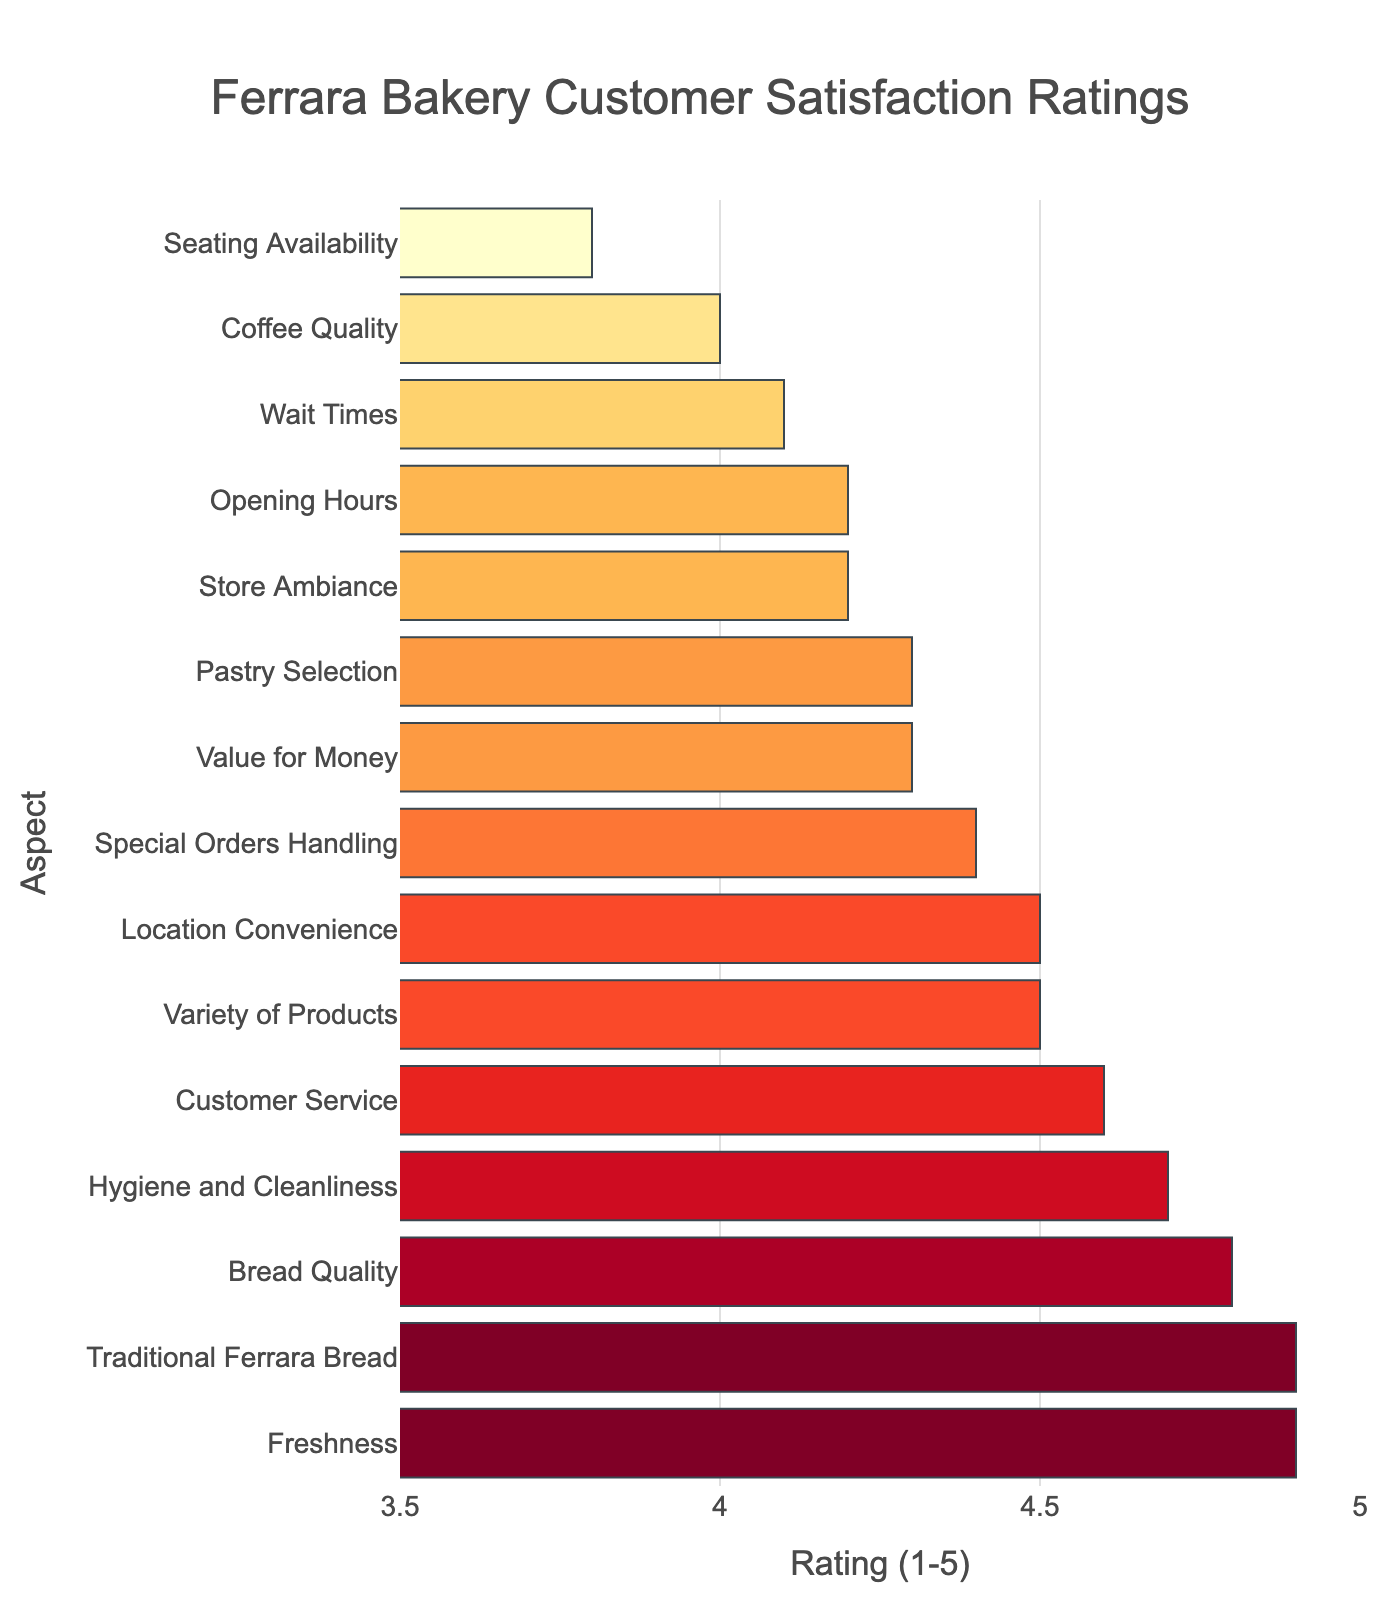How many aspects have a rating of 4.0 or below? Check each rating and count how many are 4.0 or below. In the provided data, ‘Coffee Quality’ has a rating of 4.0, and ‘Seating Availability’ has a rating of 3.8.
Answer: 2 Which aspect has the maximum customer satisfaction rating? Identify the highest rating in the data. Both ‘Freshness’ and 'Traditional Ferrara Bread' have the highest rating of 4.9.
Answer: Freshness/Traditional Ferrara Bread (Tie) What is the average rating for all aspects? Sum all ratings and divide by the number of aspects. The sum is 65.8, and there are 15 aspects: 65.8/15 = 4.39.
Answer: 4.39 Which aspects have a higher rating than the 'Store Ambiance'? 'Store Ambiance' has a rating of 4.2. Compare other ratings to find higher values: Bread Quality (4.8), Customer Service (4.6), Variety of Products (4.5), Freshness (4.9), Value for Money (4.3), Hygiene and Cleanliness (4.7), Special Orders Handling (4.4), Traditional Ferrara Bread (4.9), Location Convenience (4.5).
Answer: Bread Quality, Customer Service, Variety of Products, Freshness, Value for Money, Hygiene and Cleanliness, Special Orders Handling, Traditional Ferrara Bread, Location Convenience What is the median rating across all aspects? Arrange ratings in ascending order:  (3.8, 4.0, 4.1, 4.2, 4.2, 4.3, 4.3, 4.4, 4.5, 4.5, 4.6, 4.7, 4.8, 4.9, 4.9). The median is the middle value: (4.4 + 4.5)/2 = 4.45.
Answer: 4.45 How much higher is the rating for 'Freshness' compared to 'Wait Times'? 'Freshness' has a rating of 4.9, 'Wait Times' has a rating of 4.1. Subtract the two values: 4.9 - 4.1 = 0.8.
Answer: 0.8 Which aspect has the lowest rating, and what is it? Identify the lowest rating in the data which is 3.8 for ‘Seating Availability’.
Answer: Seating Availability, 3.8 How many aspects have a rating equal to or higher than 4.7? Identify aspects with ratings 4.7 or higher: Bread Quality (4.8), Freshness (4.9), Hygiene and Cleanliness (4.7), Traditional Ferrara Bread (4.9). There are 4 such aspects.
Answer: 4 